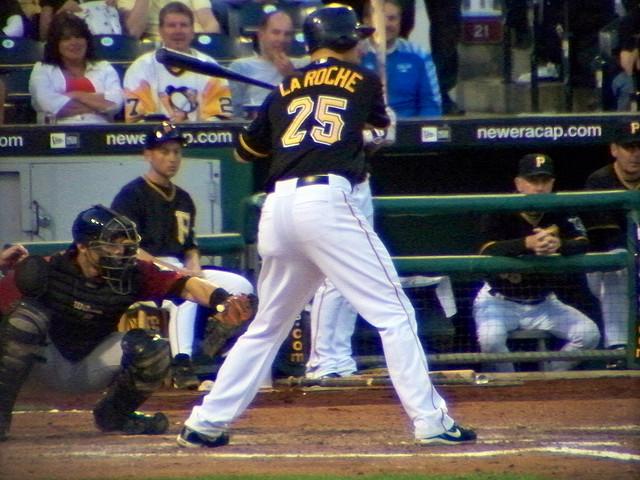Are the spectators cheering?
Concise answer only. Yes. Who letter is on the man's hat?
Be succinct. P. What is the number in the top right corner?
Be succinct. 21. Is the person batting a male?
Write a very short answer. Yes. 